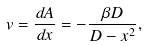<formula> <loc_0><loc_0><loc_500><loc_500>v = \frac { d A } { d x } = - \frac { \beta D } { D - x ^ { 2 } } ,</formula> 